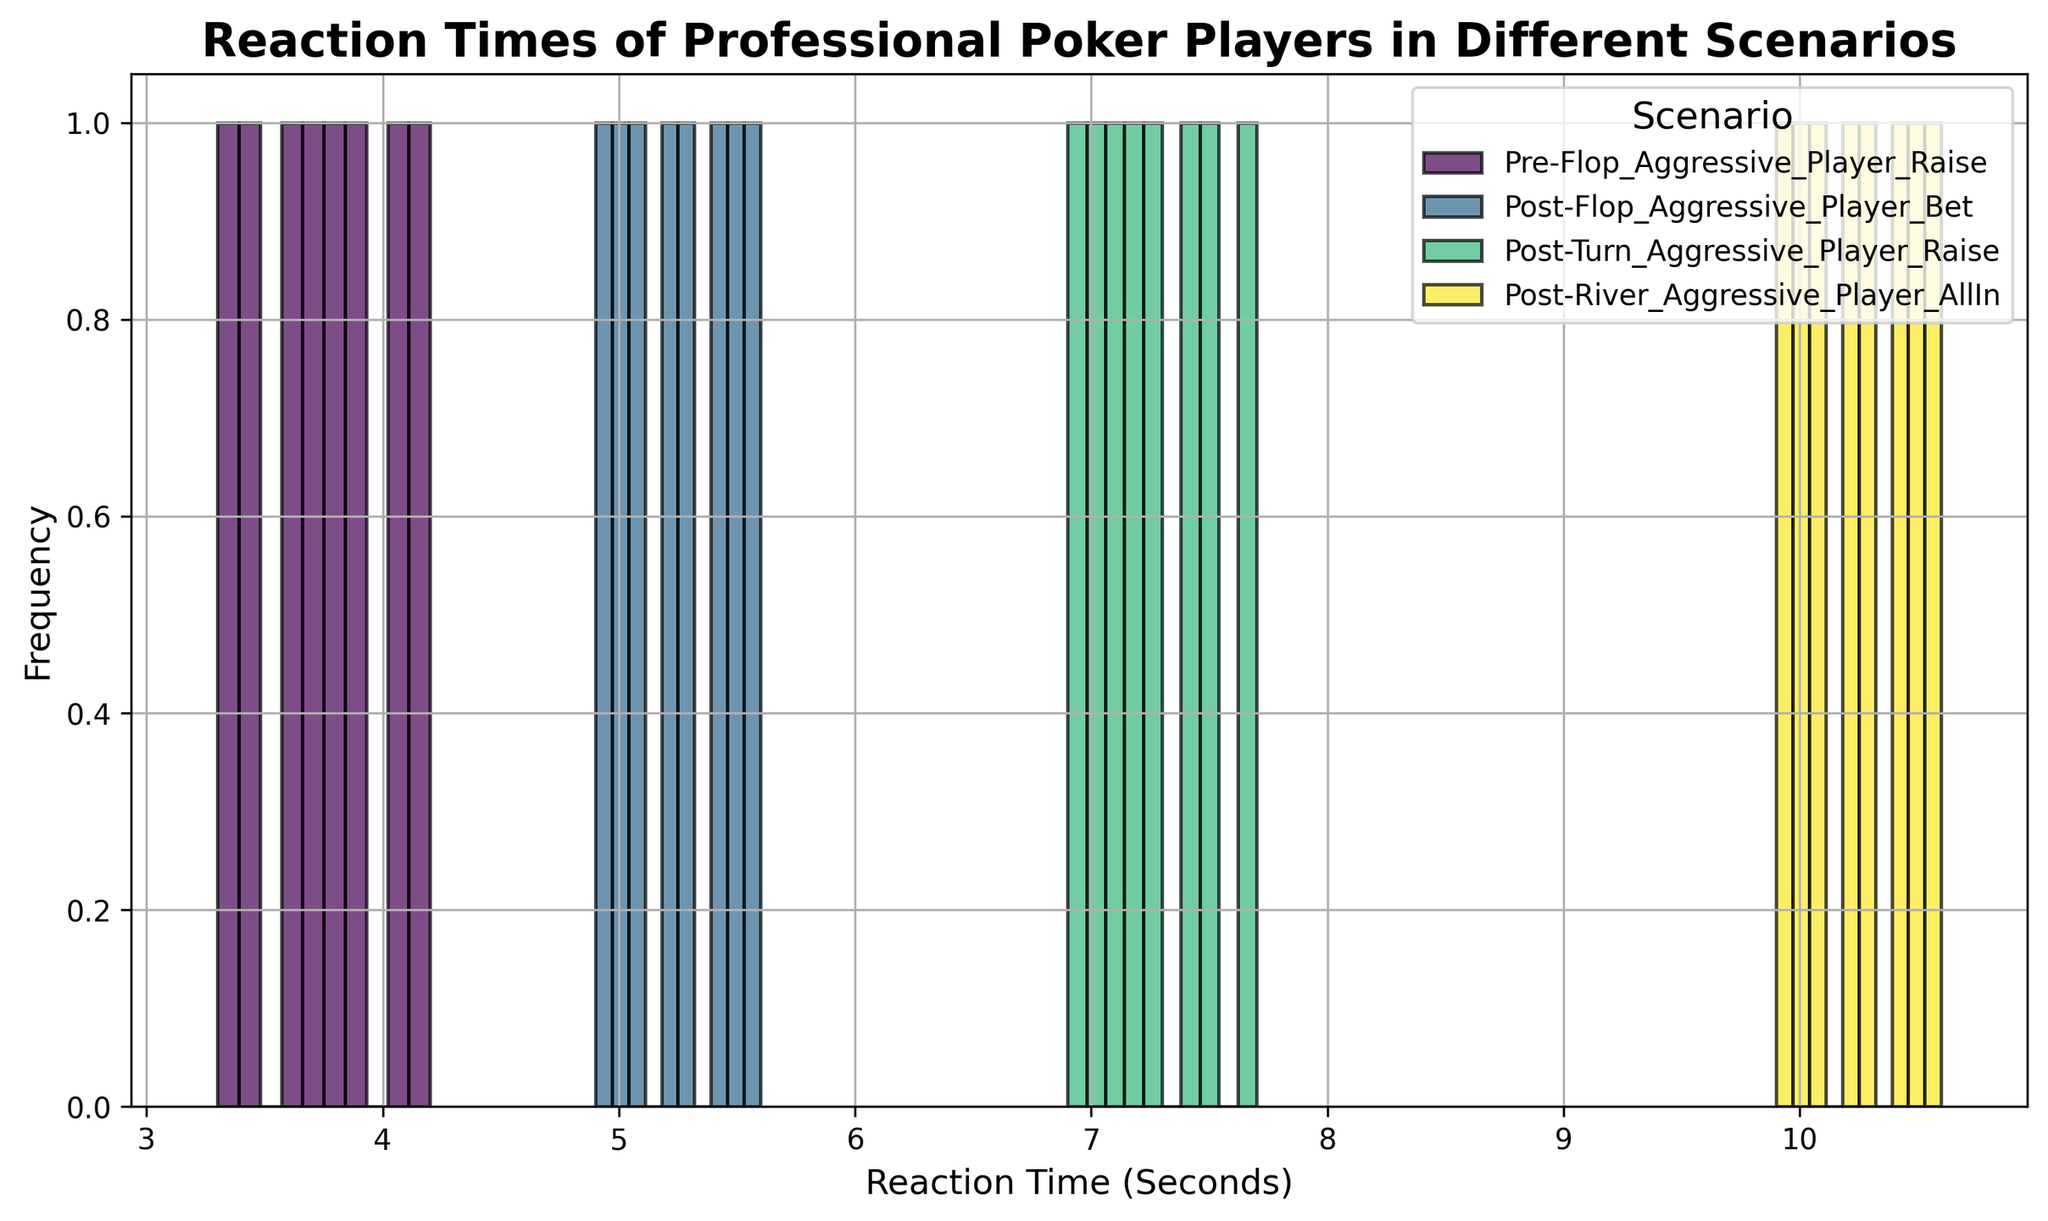Which scenario has the longest average reaction time? Look at the histograms and identify the one with the highest reaction times. Post-River Aggressive Player All-In shows times around 10 seconds, the longest among all scenarios.
Answer: Post-River Aggressive Player All-In Which scenario has the shortest reaction times? Identify the histogram with the lowest reaction times. Pre-Flop Aggressive Player Raise has times around 3.4 to 4.2 seconds, which are the shortest.
Answer: Pre-Flop Aggressive Player Raise What is the typical reaction time range for Post-Turn Aggressive Player Raise? Determine the bounds of the histogram bins for Post-Turn Aggressive Player Raise. The reaction times range from approximately 6.9 to 7.7 seconds.
Answer: 6.9 to 7.7 seconds How many different scenarios are compared in the plot? Count the number of unique histograms or labels in the legend. The figure contains four different scenarios.
Answer: 4 Which scenario has the most variation in reaction times? Evaluate the spread of the bins for each scenario. Post-River Aggressive Player All-In spans from 9.9 to 10.6 seconds, the broadest range compared to other scenarios.
Answer: Post-River Aggressive Player All-In Is there a scenario where the reaction times are mostly tightly clustered around a single value? Examine the histograms to see if most bars are concentrated in a narrow range. The Pre-Flop Aggressive Player Raise scenario has tightly clustered reaction times around 3.4 to 4.2 seconds.
Answer: Pre-Flop Aggressive Player Raise Which scenario's reaction times are concentrated near the middle of the plot? Locate the histograms that fall in the central range of the x-axis. The Post-Flop Aggressive Player Bet scenario, with times ranging from 4.9 to 5.6 seconds, is centered near the middle.
Answer: Post-Flop Aggressive Player Bet Which scenarios show reaction times extending above 10 seconds? Identify the histograms with bars exceeding 10 seconds on the x-axis. Only the Post-River Aggressive Player All-In scenario extends above 10 seconds.
Answer: Post-River Aggressive Player All-In How does the reaction time in the Post-Flop scenario compare with the Pre-Flop scenario? Compare the central values and spreads of both histograms. The Post-Flop scenario (4.9 to 5.6 seconds) has longer reaction times compared to the Pre-Flop scenario (3.4 to 4.2 seconds).
Answer: Post-Flop times are longer than Pre-Flop Which scenario shows the least increase in reaction time compared to its preceding scenario? Analyze the differences between adjacent scenarios. The increase from Post-Flop (4.9-5.6 seconds) to Post-Turn (6.9-7.7 seconds) is smaller compared to the jumps in other scenarios.
Answer: Post-Flop to Post-Turn 